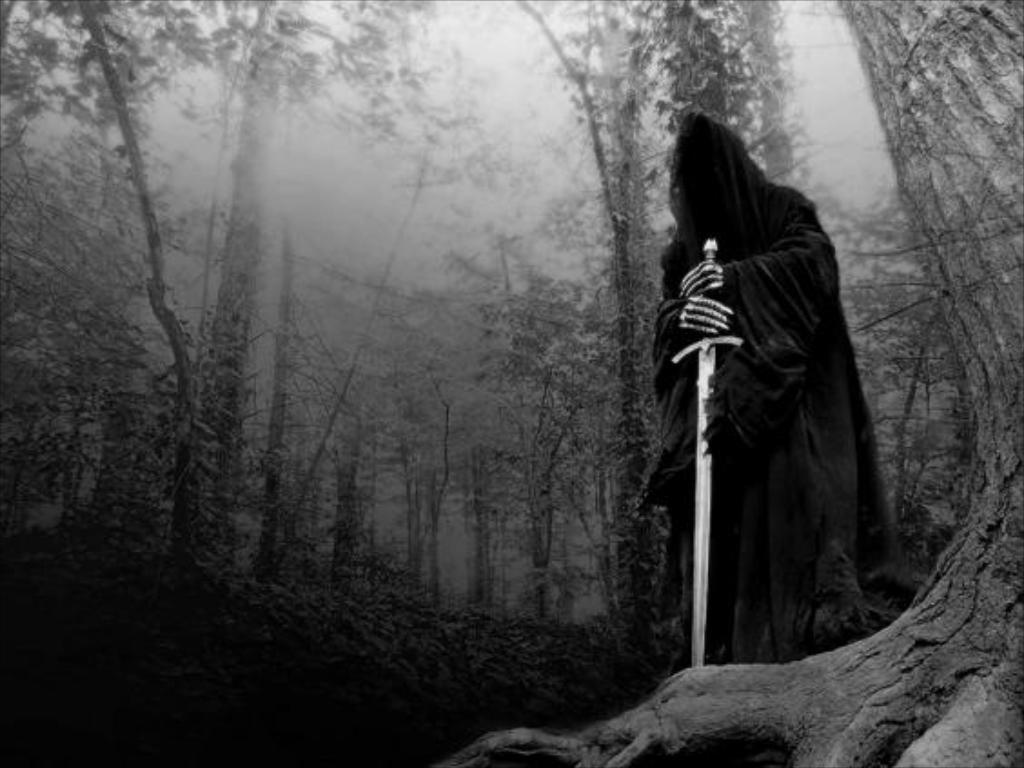What is the color scheme of the image? The image is black and white. What can be seen in the image besides the color scheme? There is a person standing in the image, and the person is holding a sword. What type of natural environment is present in the image? There are trees in the image. What atmospheric condition can be observed in the image? There is fog visible in the image. How many goats are visible in the image? There are no goats present in the image. What type of stocking is the person wearing in the image? The image is black and white, and there is no indication of any stockings being worn by the person. How many pigs can be seen in the image? There are no pigs present in the image. 